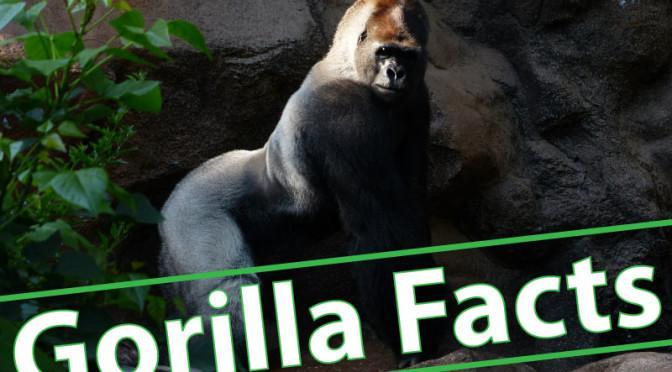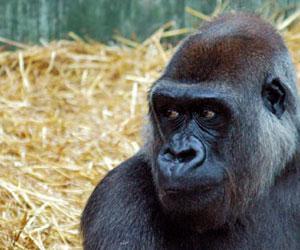The first image is the image on the left, the second image is the image on the right. Considering the images on both sides, is "An image includes a baby gorilla held in the arms of an adult gorilla." valid? Answer yes or no. No. The first image is the image on the left, the second image is the image on the right. For the images displayed, is the sentence "Multiple gorillas can be seen in the right image." factually correct? Answer yes or no. No. 